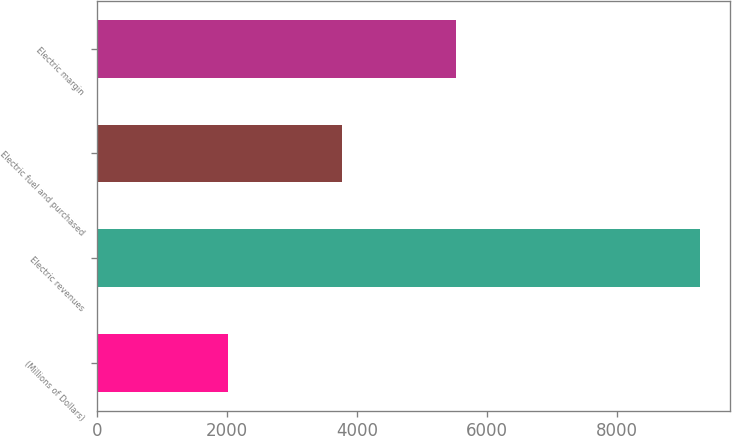Convert chart to OTSL. <chart><loc_0><loc_0><loc_500><loc_500><bar_chart><fcel>(Millions of Dollars)<fcel>Electric revenues<fcel>Electric fuel and purchased<fcel>Electric margin<nl><fcel>2015<fcel>9276<fcel>3763<fcel>5513<nl></chart> 